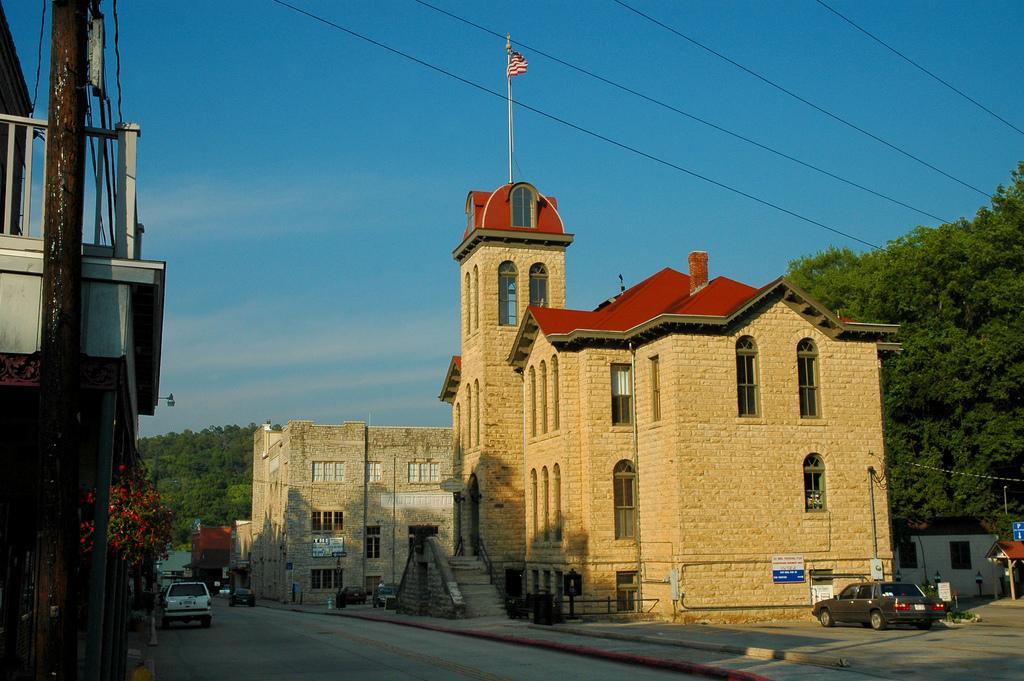Can you describe this image briefly? In the image there are two buildings on the right side, there are some vehicles around those buildings. On the right side there are a lot of trees and on the left side there is another building and behind the building there is a tree. In the background there is a lot of greenery. 